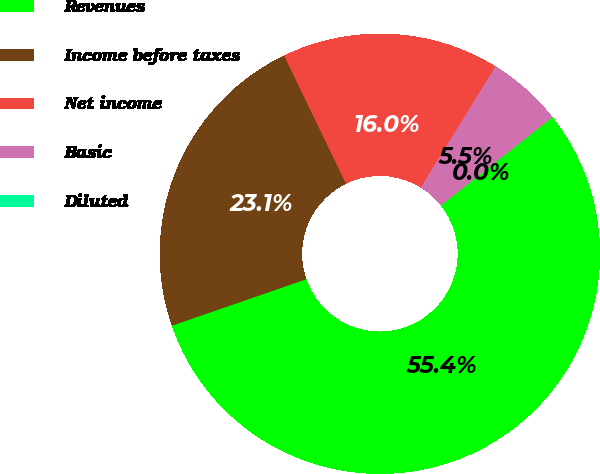Convert chart to OTSL. <chart><loc_0><loc_0><loc_500><loc_500><pie_chart><fcel>Revenues<fcel>Income before taxes<fcel>Net income<fcel>Basic<fcel>Diluted<nl><fcel>55.36%<fcel>23.14%<fcel>15.97%<fcel>5.54%<fcel>0.0%<nl></chart> 